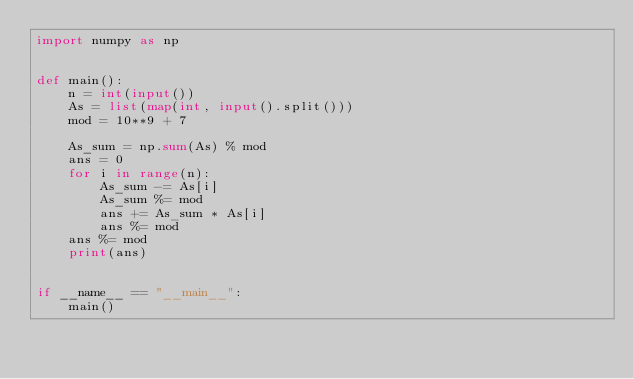<code> <loc_0><loc_0><loc_500><loc_500><_Python_>import numpy as np


def main():
    n = int(input())
    As = list(map(int, input().split()))
    mod = 10**9 + 7

    As_sum = np.sum(As) % mod
    ans = 0
    for i in range(n):
        As_sum -= As[i]
        As_sum %= mod
        ans += As_sum * As[i]
        ans %= mod
    ans %= mod
    print(ans)


if __name__ == "__main__":
    main()
</code> 